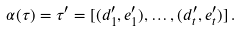Convert formula to latex. <formula><loc_0><loc_0><loc_500><loc_500>\alpha ( \tau ) = \tau ^ { \prime } = [ ( d _ { 1 } ^ { \prime } , e _ { 1 } ^ { \prime } ) , \dots , ( d _ { t } ^ { \prime } , e _ { t } ^ { \prime } ) ] \, .</formula> 